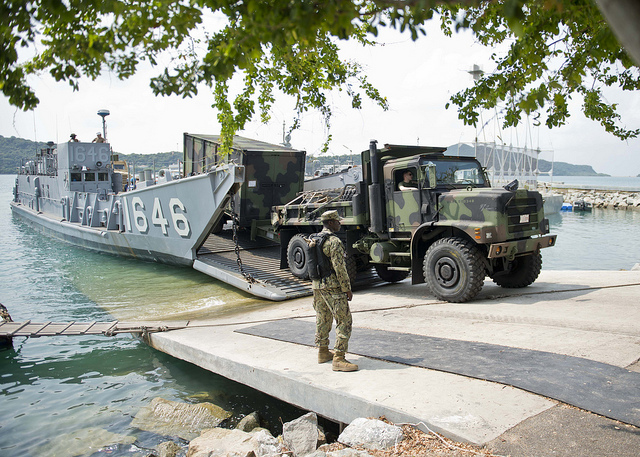What might be the challenges faced by the military personnel during this operation? The challenges faced by the military personnel during this operation might include ensuring the safe and efficient unloading of heavy armored vehicles from the landing craft to the dock. There's a risk of mechanical issues with the vehicles or the landing craft, which could delay the operation. The personnel need to be vigilant about potential security threats, as the operational environment seems exposed. Additionally, coordinating such a large-scale movement requires precise communication and leadership to avoid accidents and ensure all equipment and personnel are accounted for. What could be in the backpack of the soldier supervising the operation? The backpack of the soldier supervising the operation could contain a variety of essential items such as communication equipment like radios for coordination, essential survival gear including water and food rations, first aid kits, tools for quick repairs, and possibly personal defense equipment. Given the nature of the operation, the backpack might also include documentation and maps related to the mission. How do military operations like this one contribute to strategic military objectives? Military operations of this nature contribute significantly to strategic military objectives by ensuring that essential supplies, equipment, and personnel are efficiently and securely transported to critical locations. This ability to mobilize and position resources quickly enhances operational readiness and provides a strategic advantage in both defensive and offensive scenarios. Such operations also demonstrate logistical capabilities and preparedness, which can have a deterrent effect on potential adversaries. Additionally, these operations could be part of joint exercises with allied forces, enhancing interoperability and mutual defense capabilities. 